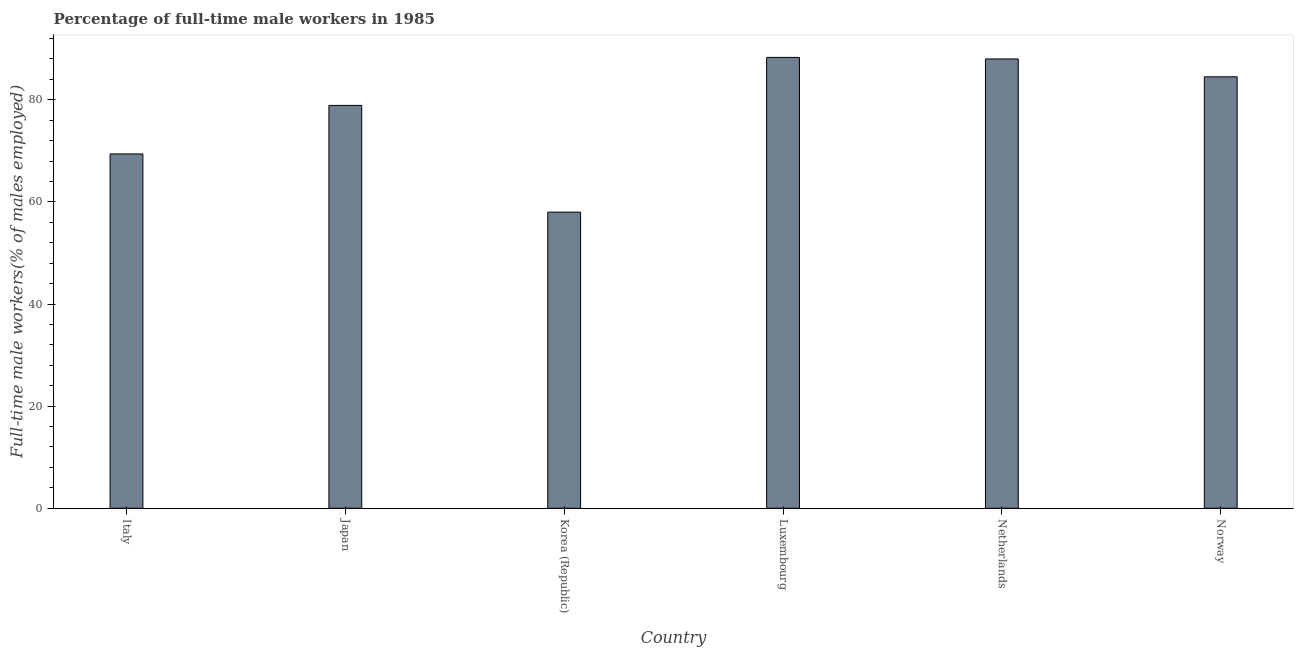Does the graph contain any zero values?
Your response must be concise. No. Does the graph contain grids?
Provide a succinct answer. No. What is the title of the graph?
Offer a very short reply. Percentage of full-time male workers in 1985. What is the label or title of the X-axis?
Your answer should be compact. Country. What is the label or title of the Y-axis?
Your answer should be very brief. Full-time male workers(% of males employed). Across all countries, what is the maximum percentage of full-time male workers?
Your answer should be compact. 88.3. In which country was the percentage of full-time male workers maximum?
Your response must be concise. Luxembourg. In which country was the percentage of full-time male workers minimum?
Ensure brevity in your answer.  Korea (Republic). What is the sum of the percentage of full-time male workers?
Your response must be concise. 467.1. What is the average percentage of full-time male workers per country?
Provide a succinct answer. 77.85. What is the median percentage of full-time male workers?
Keep it short and to the point. 81.7. What is the ratio of the percentage of full-time male workers in Luxembourg to that in Norway?
Offer a very short reply. 1.04. Is the difference between the percentage of full-time male workers in Italy and Korea (Republic) greater than the difference between any two countries?
Offer a terse response. No. What is the difference between the highest and the lowest percentage of full-time male workers?
Your answer should be very brief. 30.3. Are all the bars in the graph horizontal?
Make the answer very short. No. What is the difference between two consecutive major ticks on the Y-axis?
Your response must be concise. 20. Are the values on the major ticks of Y-axis written in scientific E-notation?
Ensure brevity in your answer.  No. What is the Full-time male workers(% of males employed) of Italy?
Provide a succinct answer. 69.4. What is the Full-time male workers(% of males employed) of Japan?
Give a very brief answer. 78.9. What is the Full-time male workers(% of males employed) of Luxembourg?
Your answer should be very brief. 88.3. What is the Full-time male workers(% of males employed) in Netherlands?
Your response must be concise. 88. What is the Full-time male workers(% of males employed) in Norway?
Offer a terse response. 84.5. What is the difference between the Full-time male workers(% of males employed) in Italy and Korea (Republic)?
Your answer should be compact. 11.4. What is the difference between the Full-time male workers(% of males employed) in Italy and Luxembourg?
Your answer should be very brief. -18.9. What is the difference between the Full-time male workers(% of males employed) in Italy and Netherlands?
Provide a short and direct response. -18.6. What is the difference between the Full-time male workers(% of males employed) in Italy and Norway?
Your answer should be very brief. -15.1. What is the difference between the Full-time male workers(% of males employed) in Japan and Korea (Republic)?
Ensure brevity in your answer.  20.9. What is the difference between the Full-time male workers(% of males employed) in Japan and Luxembourg?
Your answer should be very brief. -9.4. What is the difference between the Full-time male workers(% of males employed) in Japan and Netherlands?
Give a very brief answer. -9.1. What is the difference between the Full-time male workers(% of males employed) in Japan and Norway?
Offer a terse response. -5.6. What is the difference between the Full-time male workers(% of males employed) in Korea (Republic) and Luxembourg?
Make the answer very short. -30.3. What is the difference between the Full-time male workers(% of males employed) in Korea (Republic) and Norway?
Offer a very short reply. -26.5. What is the difference between the Full-time male workers(% of males employed) in Luxembourg and Netherlands?
Provide a succinct answer. 0.3. What is the difference between the Full-time male workers(% of males employed) in Netherlands and Norway?
Offer a terse response. 3.5. What is the ratio of the Full-time male workers(% of males employed) in Italy to that in Japan?
Give a very brief answer. 0.88. What is the ratio of the Full-time male workers(% of males employed) in Italy to that in Korea (Republic)?
Give a very brief answer. 1.2. What is the ratio of the Full-time male workers(% of males employed) in Italy to that in Luxembourg?
Offer a very short reply. 0.79. What is the ratio of the Full-time male workers(% of males employed) in Italy to that in Netherlands?
Ensure brevity in your answer.  0.79. What is the ratio of the Full-time male workers(% of males employed) in Italy to that in Norway?
Keep it short and to the point. 0.82. What is the ratio of the Full-time male workers(% of males employed) in Japan to that in Korea (Republic)?
Your answer should be compact. 1.36. What is the ratio of the Full-time male workers(% of males employed) in Japan to that in Luxembourg?
Provide a succinct answer. 0.89. What is the ratio of the Full-time male workers(% of males employed) in Japan to that in Netherlands?
Your answer should be very brief. 0.9. What is the ratio of the Full-time male workers(% of males employed) in Japan to that in Norway?
Provide a succinct answer. 0.93. What is the ratio of the Full-time male workers(% of males employed) in Korea (Republic) to that in Luxembourg?
Offer a terse response. 0.66. What is the ratio of the Full-time male workers(% of males employed) in Korea (Republic) to that in Netherlands?
Make the answer very short. 0.66. What is the ratio of the Full-time male workers(% of males employed) in Korea (Republic) to that in Norway?
Offer a terse response. 0.69. What is the ratio of the Full-time male workers(% of males employed) in Luxembourg to that in Norway?
Make the answer very short. 1.04. What is the ratio of the Full-time male workers(% of males employed) in Netherlands to that in Norway?
Make the answer very short. 1.04. 